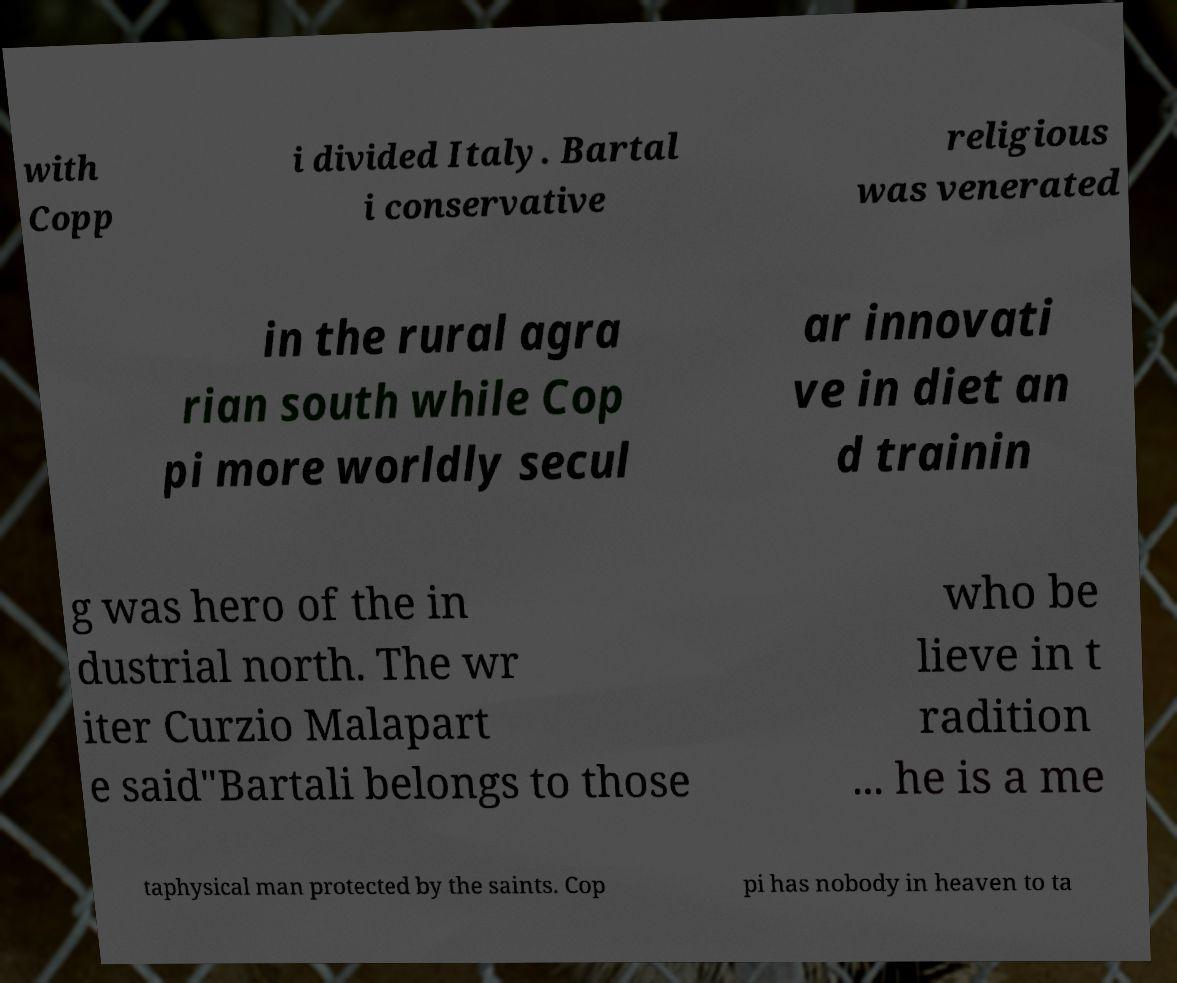Can you read and provide the text displayed in the image?This photo seems to have some interesting text. Can you extract and type it out for me? with Copp i divided Italy. Bartal i conservative religious was venerated in the rural agra rian south while Cop pi more worldly secul ar innovati ve in diet an d trainin g was hero of the in dustrial north. The wr iter Curzio Malapart e said"Bartali belongs to those who be lieve in t radition ... he is a me taphysical man protected by the saints. Cop pi has nobody in heaven to ta 